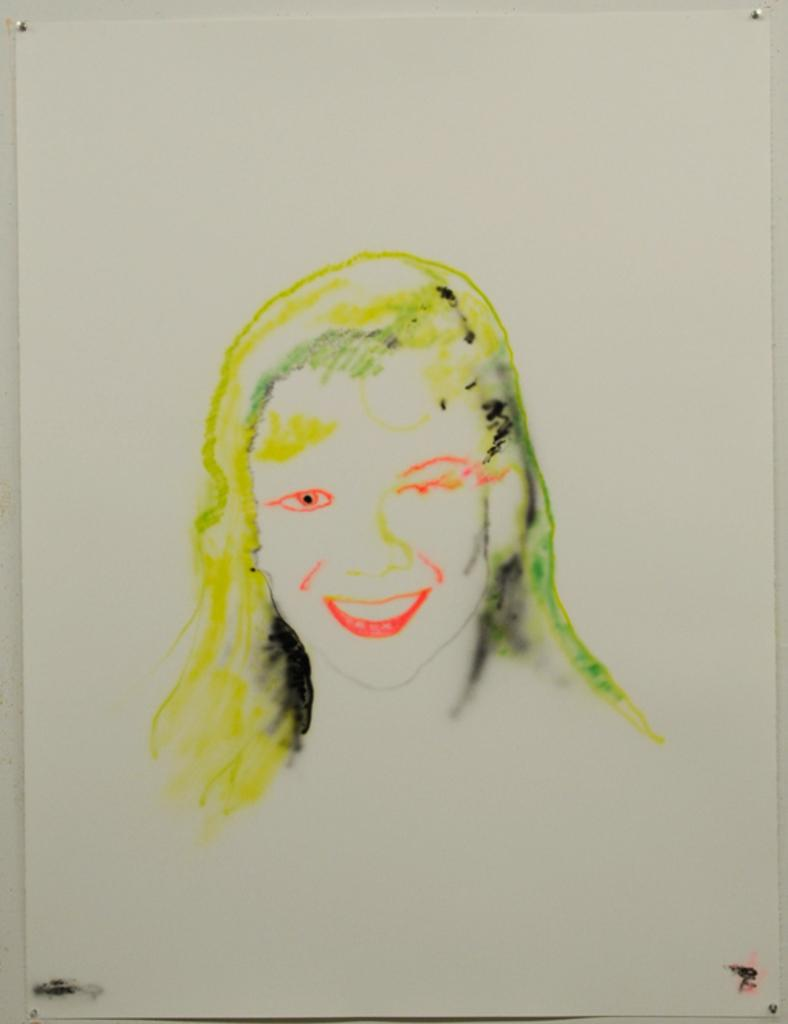What is attached to the wall in the image? There is a paper attached to the wall in the image. What is depicted on the paper? The paper contains a painting of a girl. How many planes does the girl in the painting own? The image does not provide any information about the girl's wealth or ownership of planes, as it only shows a painting of a girl on a paper. 